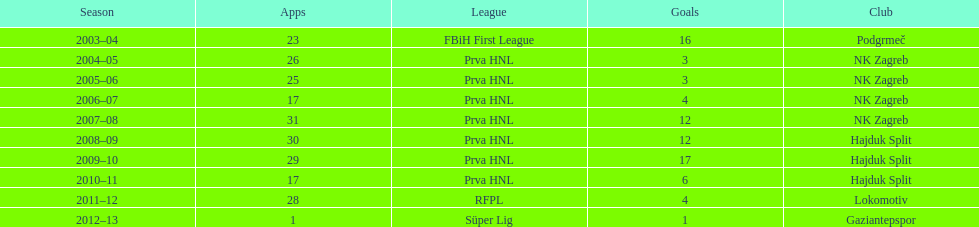After scoring against bulgaria in zenica, ibricic also scored against this team in a 7-0 victory in zenica less then a month after the friendly match against bulgaria. Estonia. Write the full table. {'header': ['Season', 'Apps', 'League', 'Goals', 'Club'], 'rows': [['2003–04', '23', 'FBiH First League', '16', 'Podgrmeč'], ['2004–05', '26', 'Prva HNL', '3', 'NK Zagreb'], ['2005–06', '25', 'Prva HNL', '3', 'NK Zagreb'], ['2006–07', '17', 'Prva HNL', '4', 'NK Zagreb'], ['2007–08', '31', 'Prva HNL', '12', 'NK Zagreb'], ['2008–09', '30', 'Prva HNL', '12', 'Hajduk Split'], ['2009–10', '29', 'Prva HNL', '17', 'Hajduk Split'], ['2010–11', '17', 'Prva HNL', '6', 'Hajduk Split'], ['2011–12', '28', 'RFPL', '4', 'Lokomotiv'], ['2012–13', '1', 'Süper Lig', '1', 'Gaziantepspor']]} 